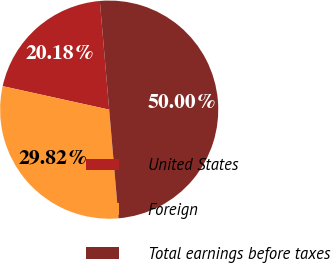<chart> <loc_0><loc_0><loc_500><loc_500><pie_chart><fcel>United States<fcel>Foreign<fcel>Total earnings before taxes<nl><fcel>20.18%<fcel>29.82%<fcel>50.0%<nl></chart> 